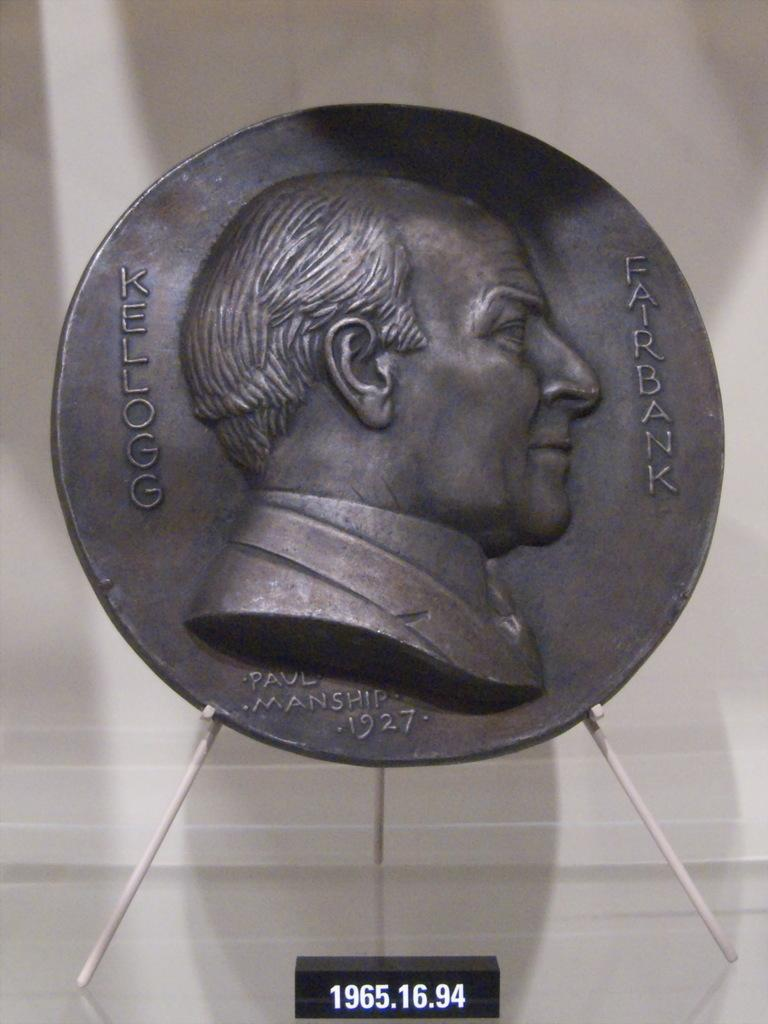<image>
Offer a succinct explanation of the picture presented. Coin with Fairbank and his face on the coin 